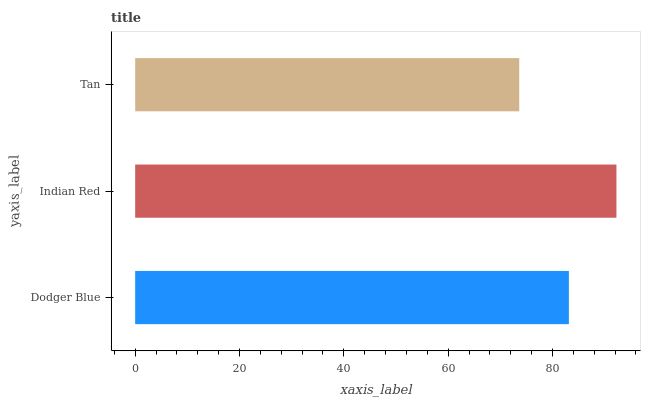Is Tan the minimum?
Answer yes or no. Yes. Is Indian Red the maximum?
Answer yes or no. Yes. Is Indian Red the minimum?
Answer yes or no. No. Is Tan the maximum?
Answer yes or no. No. Is Indian Red greater than Tan?
Answer yes or no. Yes. Is Tan less than Indian Red?
Answer yes or no. Yes. Is Tan greater than Indian Red?
Answer yes or no. No. Is Indian Red less than Tan?
Answer yes or no. No. Is Dodger Blue the high median?
Answer yes or no. Yes. Is Dodger Blue the low median?
Answer yes or no. Yes. Is Tan the high median?
Answer yes or no. No. Is Tan the low median?
Answer yes or no. No. 